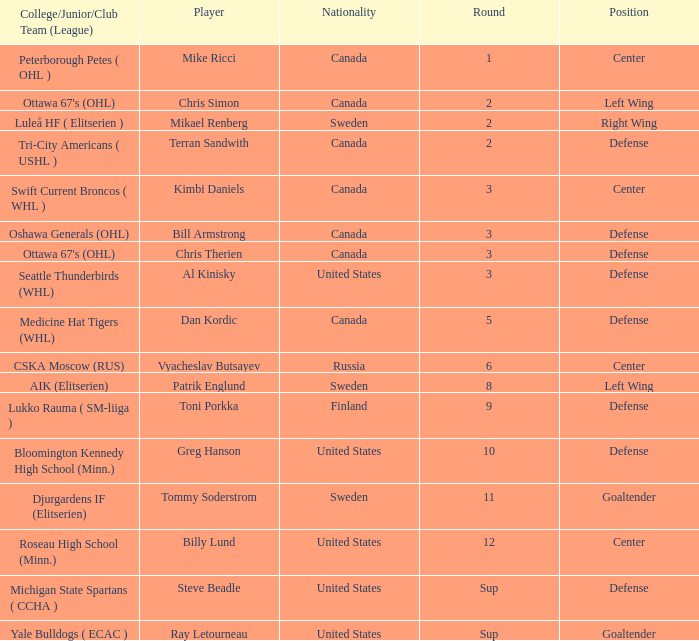What is the school that hosts mikael renberg Luleå HF ( Elitserien ). 